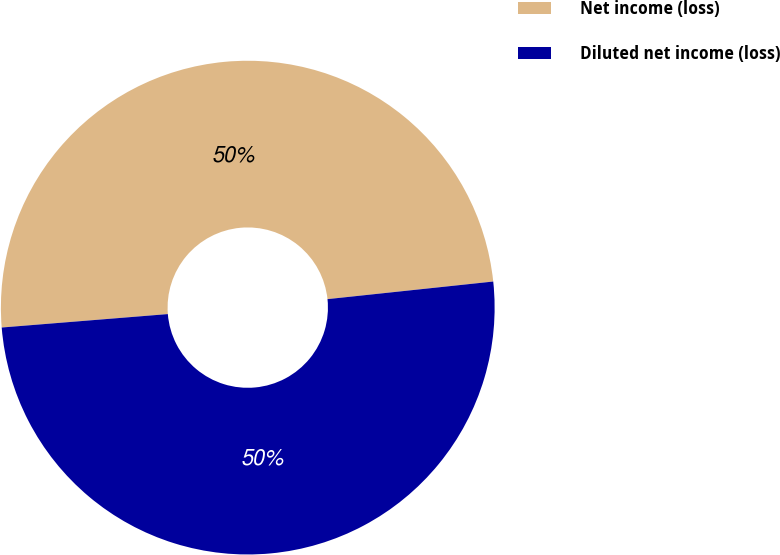Convert chart to OTSL. <chart><loc_0><loc_0><loc_500><loc_500><pie_chart><fcel>Net income (loss)<fcel>Diluted net income (loss)<nl><fcel>49.6%<fcel>50.4%<nl></chart> 